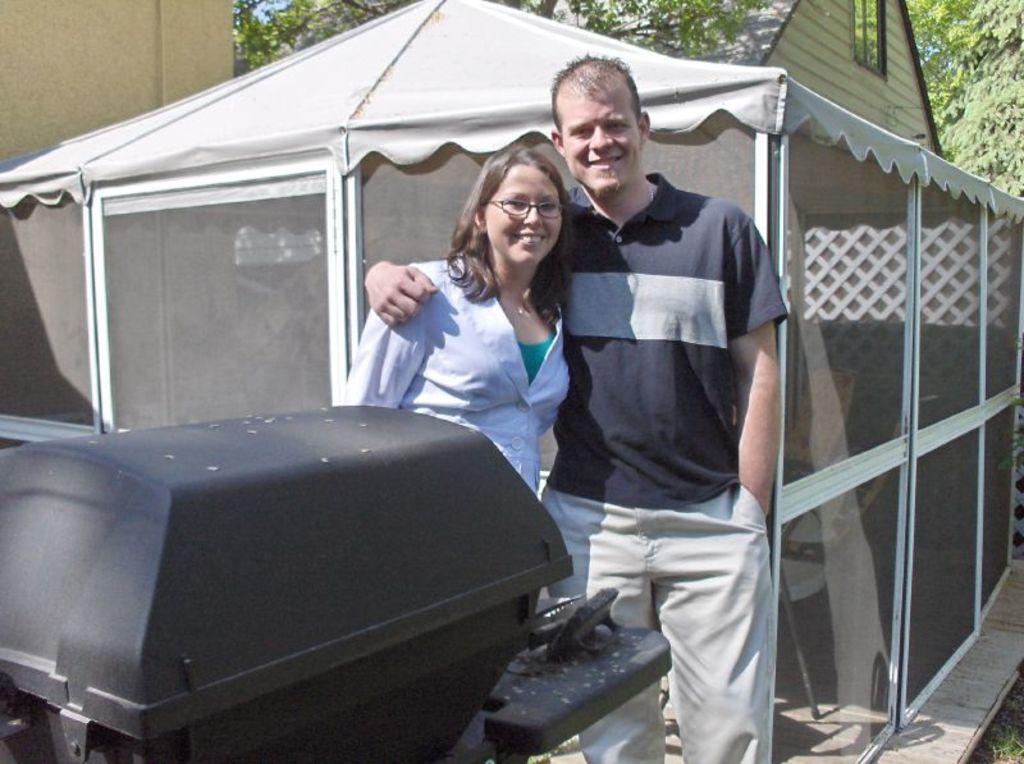Describe this image in one or two sentences. In this image there is a couple in the middle. There is a man on the right side who kept his hand on the woman's shoulder. In the background there is a tent. On the left side there is a dustbin. Behind the text there is a building and trees. 